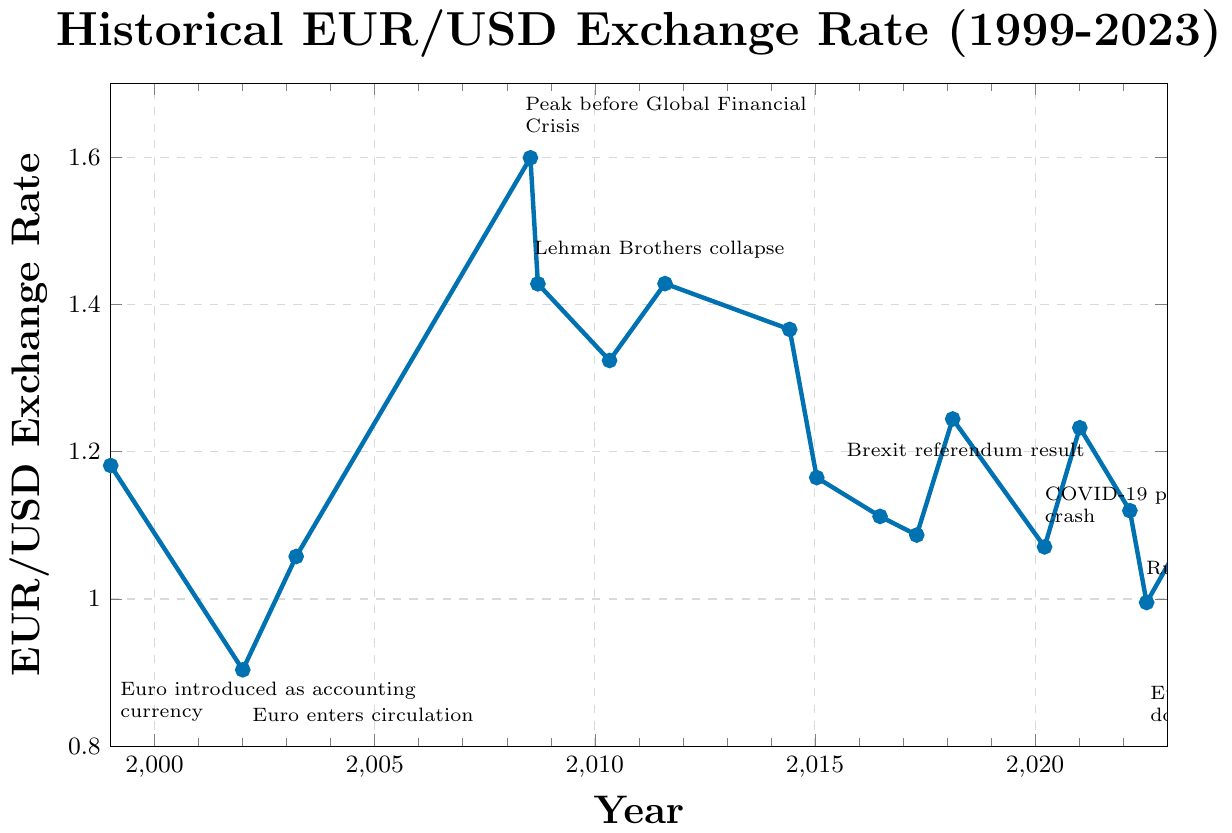When did the euro reach parity with the US dollar? The annotation indicates that the euro reached parity with the US dollar in July 2022.
Answer: July 2022 What was the EUR/USD exchange rate around the time of the Global Financial Crisis peak and the Lehman Brothers collapse? From the data points, the EUR/USD exchange rate was 1.5990 at its peak before the Global Financial Crisis in July 2008, and it was 1.4279 during the Lehman Brothers collapse in September 2008.
Answer: 1.5990 (July 2008), 1.4279 (September 2008) How did the exchange rate change between the introduction of the euro as an accounting currency and when it entered circulation? The EUR/USD exchange rate was 1.1812 when the euro was introduced as an accounting currency in January 1999 and decreased to 0.9038 when it entered circulation in January 2002.
Answer: Decreased to 0.9038 Which major event corresponds to the lowest exchange rate in the given data? The annotation shows that the lowest exchange rate (0.9952) occurred when the euro reached parity with the US dollar in July 2022.
Answer: Euro reaches parity with US dollar What was the general trend of the EUR/USD exchange rate between 2014 and 2020? Examining the data points and annotations, from 2014 (1.3660) to 2020 (1.0707), the general trend of the EUR/USD exchange rate shows a decline.
Answer: Decline How did the exchange rate respond to the Brexit referendum result in June 2016? The EUR/USD exchange rate in June 2016 was 1.1121, and it had dropped from 1.1648 the previous year.
Answer: Dropped to 1.1121 Which event happened close to the exchange rate of 1.1648, and in what year did it occur? The data shows that the EUR/USD exchange rate was 1.1648 around the time when the Swiss National Bank removed the euro cap in January 2015.
Answer: Swiss National Bank removes euro cap, January 2015 How did the exchange rate change after the S&P downgraded the US credit rating in 2011? The EUR/USD rate was around 1.4282 in August 2011 and slightly decreased afterward. Comparing it to the next visible data point in 2014, it dropped to 1.3660.
Answer: Decreased slightly How many years after the euro entered circulation did the Greek debt crisis bailout announcement occur, and what was the exchange rate at that time? The euro entered circulation in January 2002, and the Greek debt crisis bailout was announced in May 2010, which is around 8 years later. The EUR/USD exchange rate was 1.3238 at that time.
Answer: 8 years, 1.3238 